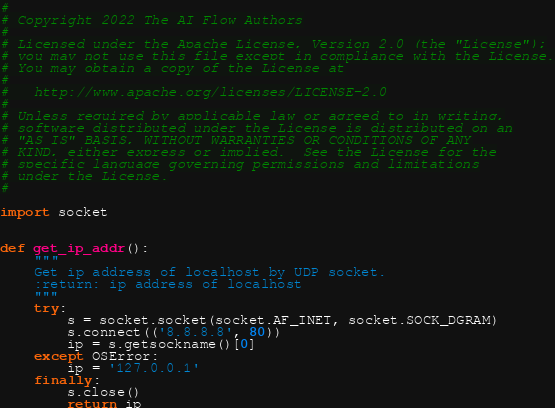<code> <loc_0><loc_0><loc_500><loc_500><_Python_>#
# Copyright 2022 The AI Flow Authors
#
# Licensed under the Apache License, Version 2.0 (the "License");
# you may not use this file except in compliance with the License.
# You may obtain a copy of the License at
#
#   http://www.apache.org/licenses/LICENSE-2.0
#
# Unless required by applicable law or agreed to in writing,
# software distributed under the License is distributed on an
# "AS IS" BASIS, WITHOUT WARRANTIES OR CONDITIONS OF ANY
# KIND, either express or implied.  See the License for the
# specific language governing permissions and limitations
# under the License.
#

import socket


def get_ip_addr():
    """
    Get ip address of localhost by UDP socket.
    :return: ip address of localhost
    """
    try:
        s = socket.socket(socket.AF_INET, socket.SOCK_DGRAM)
        s.connect(('8.8.8.8', 80))
        ip = s.getsockname()[0]
    except OSError:
        ip = '127.0.0.1'
    finally:
        s.close()
        return ip
</code> 